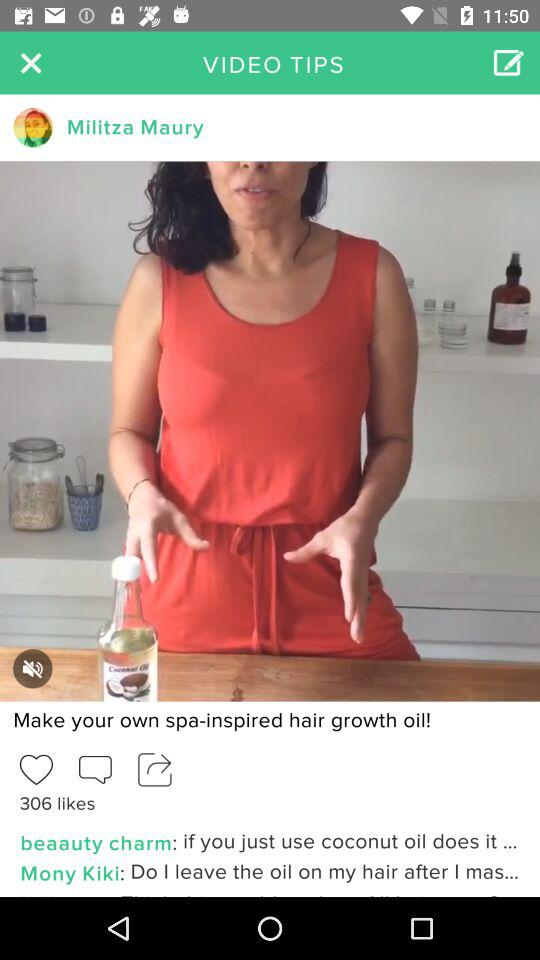How many likes are there of the video? There are 306 likes of the video. 